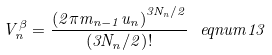<formula> <loc_0><loc_0><loc_500><loc_500>V _ { n } ^ { \beta } = \frac { \left ( 2 \pi m _ { n - 1 } u _ { n } \right ) ^ { 3 N _ { n } / 2 } } { \left ( 3 N _ { n } / 2 \right ) ! } \ e q n u m { 1 3 }</formula> 